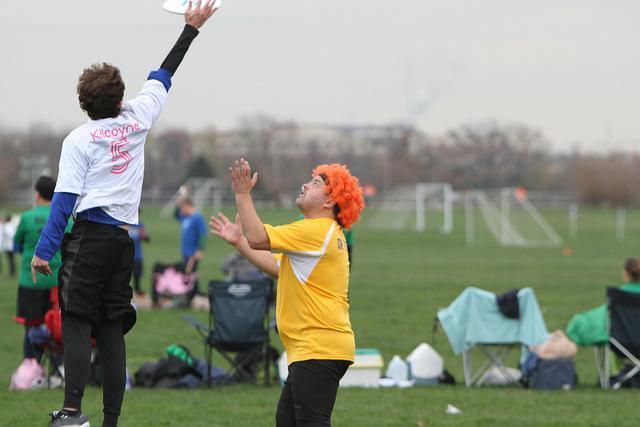How many people are in the picture?
Give a very brief answer. 5. How many chairs can you see?
Give a very brief answer. 4. How many giraffes in this photo?
Give a very brief answer. 0. 